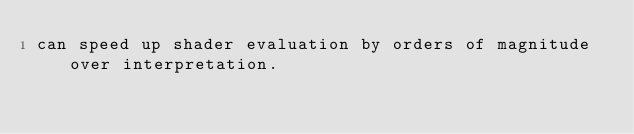<code> <loc_0><loc_0><loc_500><loc_500><_HTML_>can speed up shader evaluation by orders of magnitude over interpretation.
</code> 